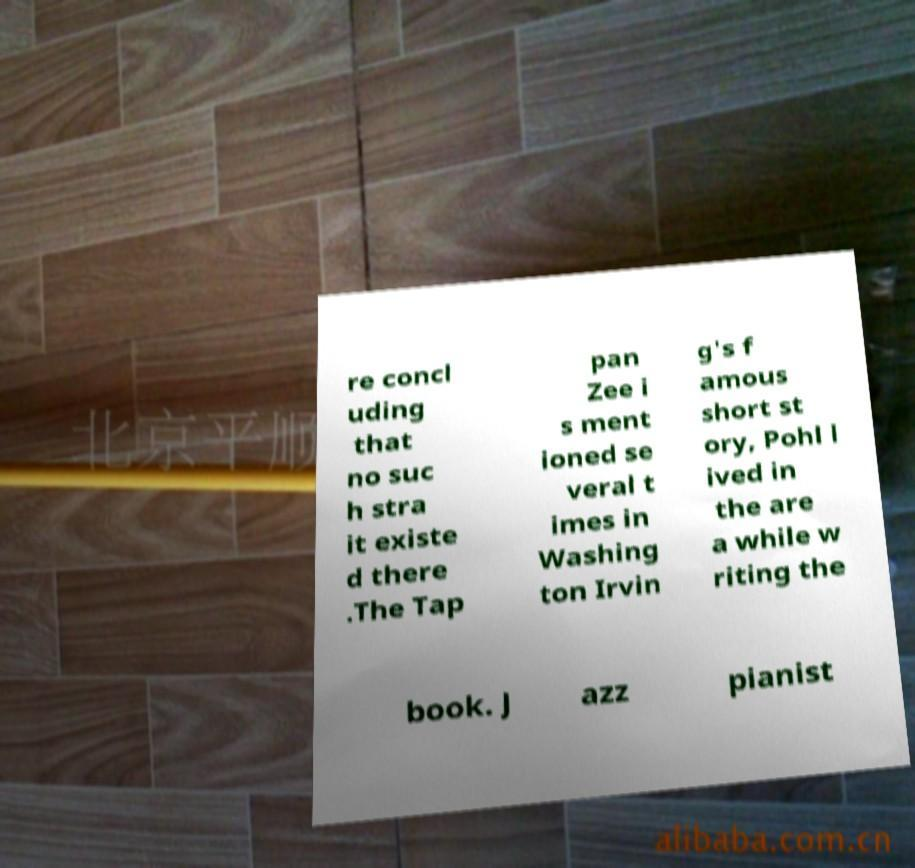Could you assist in decoding the text presented in this image and type it out clearly? re concl uding that no suc h stra it existe d there .The Tap pan Zee i s ment ioned se veral t imes in Washing ton Irvin g's f amous short st ory, Pohl l ived in the are a while w riting the book. J azz pianist 